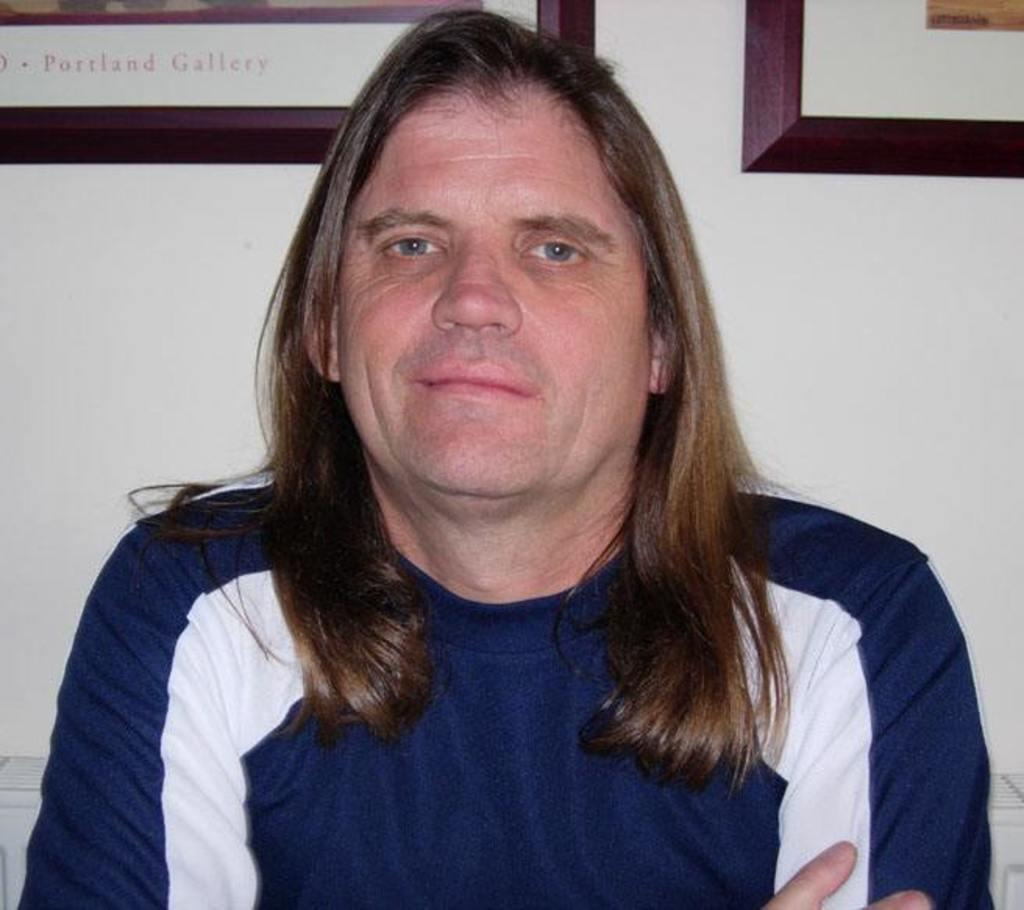What is the color of the wall in the image? There is a white color wall in the image. What can be seen hanging on the wall in the image? There is a photo frame in the image. Who is present in the image? A man is present in the image. What is the man wearing in the image? The man is wearing a blue color dress. What sense does the spoon in the image represent? There is no spoon present in the image, so it does not represent any sense. How many people are present in the image? There is only one person, a man, present in the image. 